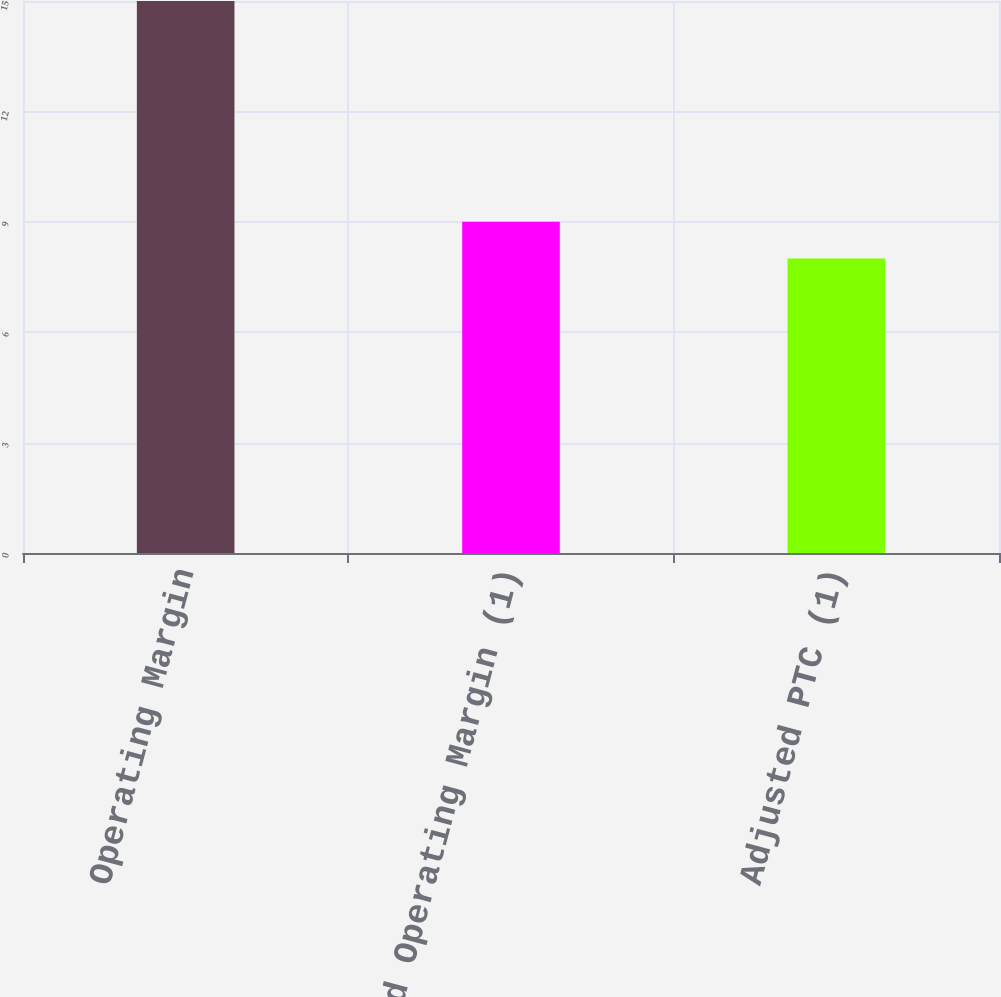Convert chart to OTSL. <chart><loc_0><loc_0><loc_500><loc_500><bar_chart><fcel>Operating Margin<fcel>Adjusted Operating Margin (1)<fcel>Adjusted PTC (1)<nl><fcel>15<fcel>9<fcel>8<nl></chart> 